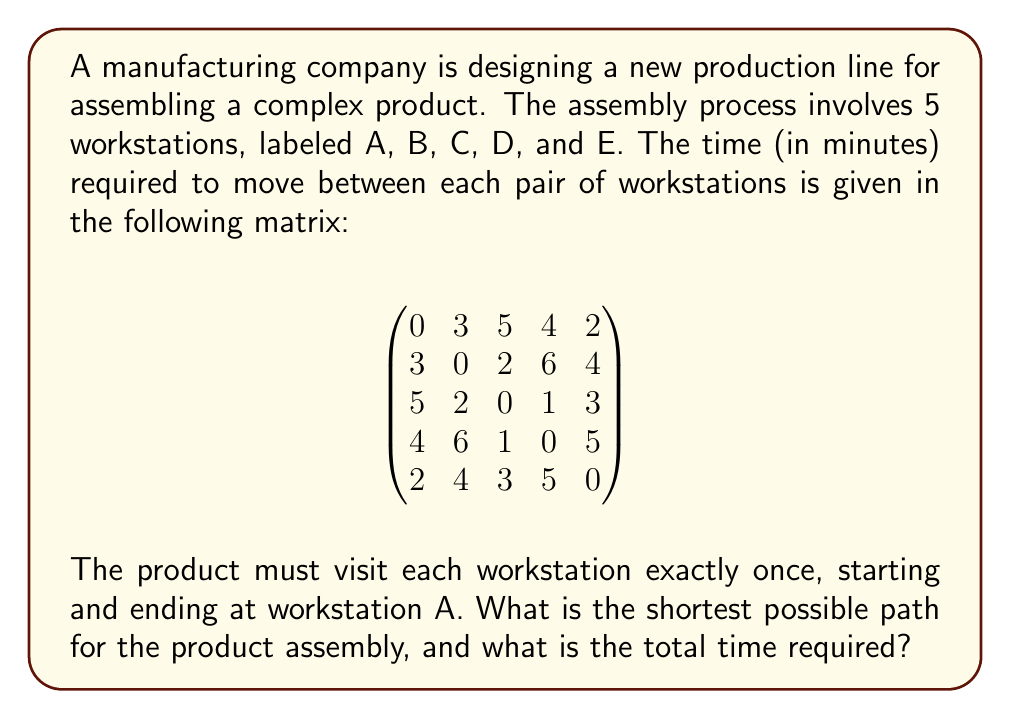Give your solution to this math problem. This problem is an instance of the Traveling Salesman Problem (TSP) in graph theory, which is NP-hard. For a small number of nodes like in this case, we can solve it using a brute-force approach.

1) First, we need to list all possible paths starting and ending at A:
   ABCDEA, ABCEDA, ABDCEA, ABDECA, ACBDEA, ACBEDA, ACDBEA, ACDEBA, ADCBEA, ADCEBA, ADBCEA, ADBECA

2) For each path, we calculate the total time by summing the times between consecutive workstations:

   ABCDEA: 3 + 2 + 1 + 5 + 2 = 13
   ABCEDA: 3 + 2 + 1 + 5 + 2 = 13
   ABDCEA: 3 + 6 + 1 + 3 + 2 = 15
   ABDECA: 3 + 6 + 5 + 3 + 2 = 19
   ACBDEA: 5 + 2 + 6 + 5 + 2 = 20
   ACBEDA: 5 + 2 + 6 + 4 + 2 = 19
   ACDBEA: 5 + 1 + 6 + 4 + 2 = 18
   ACDEBA: 5 + 1 + 5 + 4 + 2 = 17
   ADCBEA: 4 + 1 + 2 + 4 + 2 = 13
   ADCEBA: 4 + 1 + 3 + 4 + 2 = 14
   ADBCEA: 4 + 6 + 2 + 3 + 2 = 17
   ADBECA: 4 + 6 + 4 + 3 + 2 = 19

3) The shortest paths are ABCDEA, ABCEDA, and ADCBEA, all with a total time of 13 minutes.
Answer: The shortest possible paths are ABCDEA, ABCEDA, or ADCBEA, with a total time of 13 minutes. 